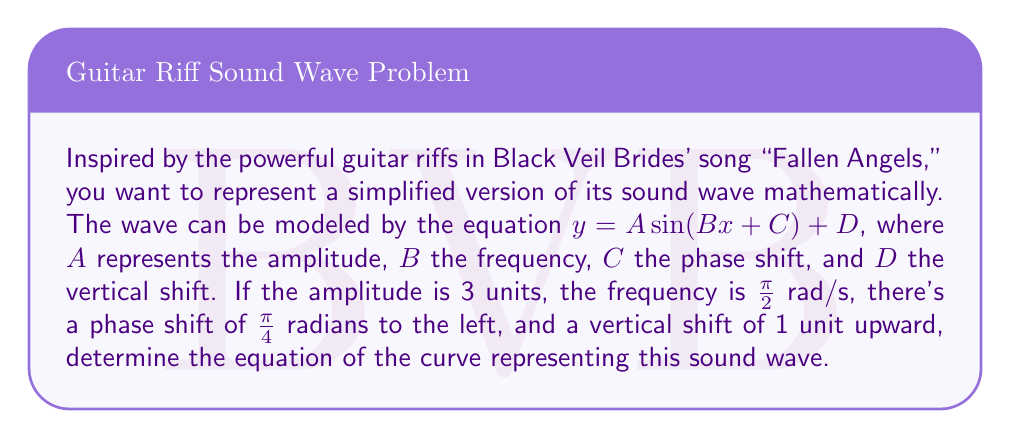Could you help me with this problem? Let's break this down step-by-step:

1) The general form of a sine wave is:
   $y = A \sin(Bx + C) + D$

2) We're given the following information:
   - Amplitude (A) = 3 units
   - Frequency (B) = $\frac{\pi}{2}$ rad/s
   - Phase shift (C) = $\frac{\pi}{4}$ radians to the left
   - Vertical shift (D) = 1 unit upward

3) For the amplitude and vertical shift, we can directly substitute the values:
   $y = 3 \sin(Bx + C) + 1$

4) For the frequency, we substitute $B = \frac{\pi}{2}$:
   $y = 3 \sin(\frac{\pi}{2}x + C) + 1$

5) For the phase shift, we need to be careful. A phase shift of $\frac{\pi}{4}$ to the left is equivalent to adding $\frac{\pi}{4}$ inside the parentheses:
   $y = 3 \sin(\frac{\pi}{2}x + \frac{\pi}{4}) + 1$

6) Therefore, the final equation of the curve representing this sound wave is:
   $y = 3 \sin(\frac{\pi}{2}x + \frac{\pi}{4}) + 1$

This equation represents a sine wave with an amplitude of 3, a period of $4$ (since $\frac{2\pi}{B} = \frac{2\pi}{\frac{\pi}{2}} = 4$), shifted $\frac{\pi}{2}$ units to the left, and 1 unit up from the x-axis.
Answer: $y = 3 \sin(\frac{\pi}{2}x + \frac{\pi}{4}) + 1$ 